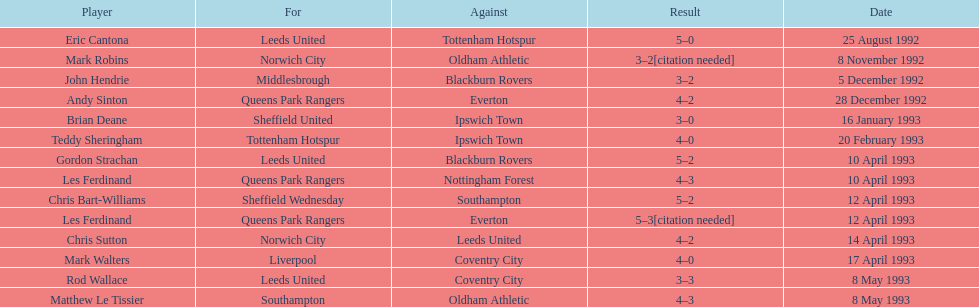Who did southampton compete against on may 8th, 1993? Oldham Athletic. 